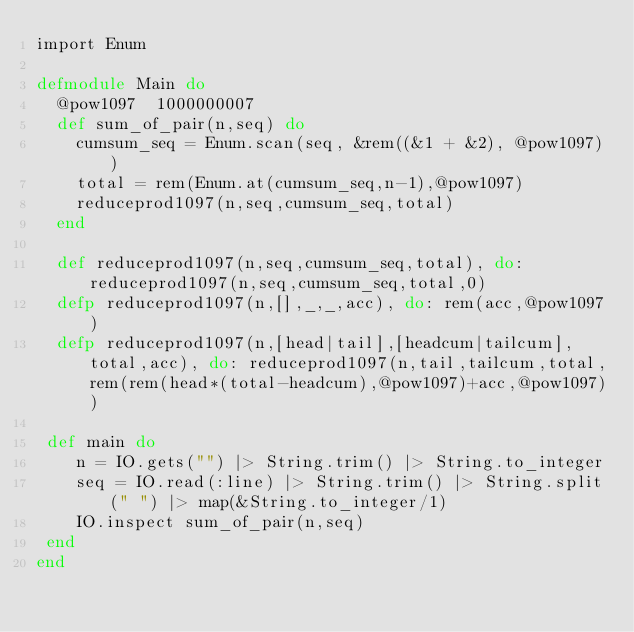Convert code to text. <code><loc_0><loc_0><loc_500><loc_500><_Elixir_>import Enum
 
defmodule Main do
  @pow1097  1000000007
  def sum_of_pair(n,seq) do
    cumsum_seq = Enum.scan(seq, &rem((&1 + &2), @pow1097))
    total = rem(Enum.at(cumsum_seq,n-1),@pow1097)
    reduceprod1097(n,seq,cumsum_seq,total)
  end
  
  def reduceprod1097(n,seq,cumsum_seq,total), do: reduceprod1097(n,seq,cumsum_seq,total,0)
  defp reduceprod1097(n,[],_,_,acc), do: rem(acc,@pow1097) 
  defp reduceprod1097(n,[head|tail],[headcum|tailcum],total,acc), do: reduceprod1097(n,tail,tailcum,total,rem(rem(head*(total-headcum),@pow1097)+acc,@pow1097))
  
 def main do
    n = IO.gets("") |> String.trim() |> String.to_integer
    seq = IO.read(:line) |> String.trim() |> String.split(" ") |> map(&String.to_integer/1)
    IO.inspect sum_of_pair(n,seq)
 end
end</code> 